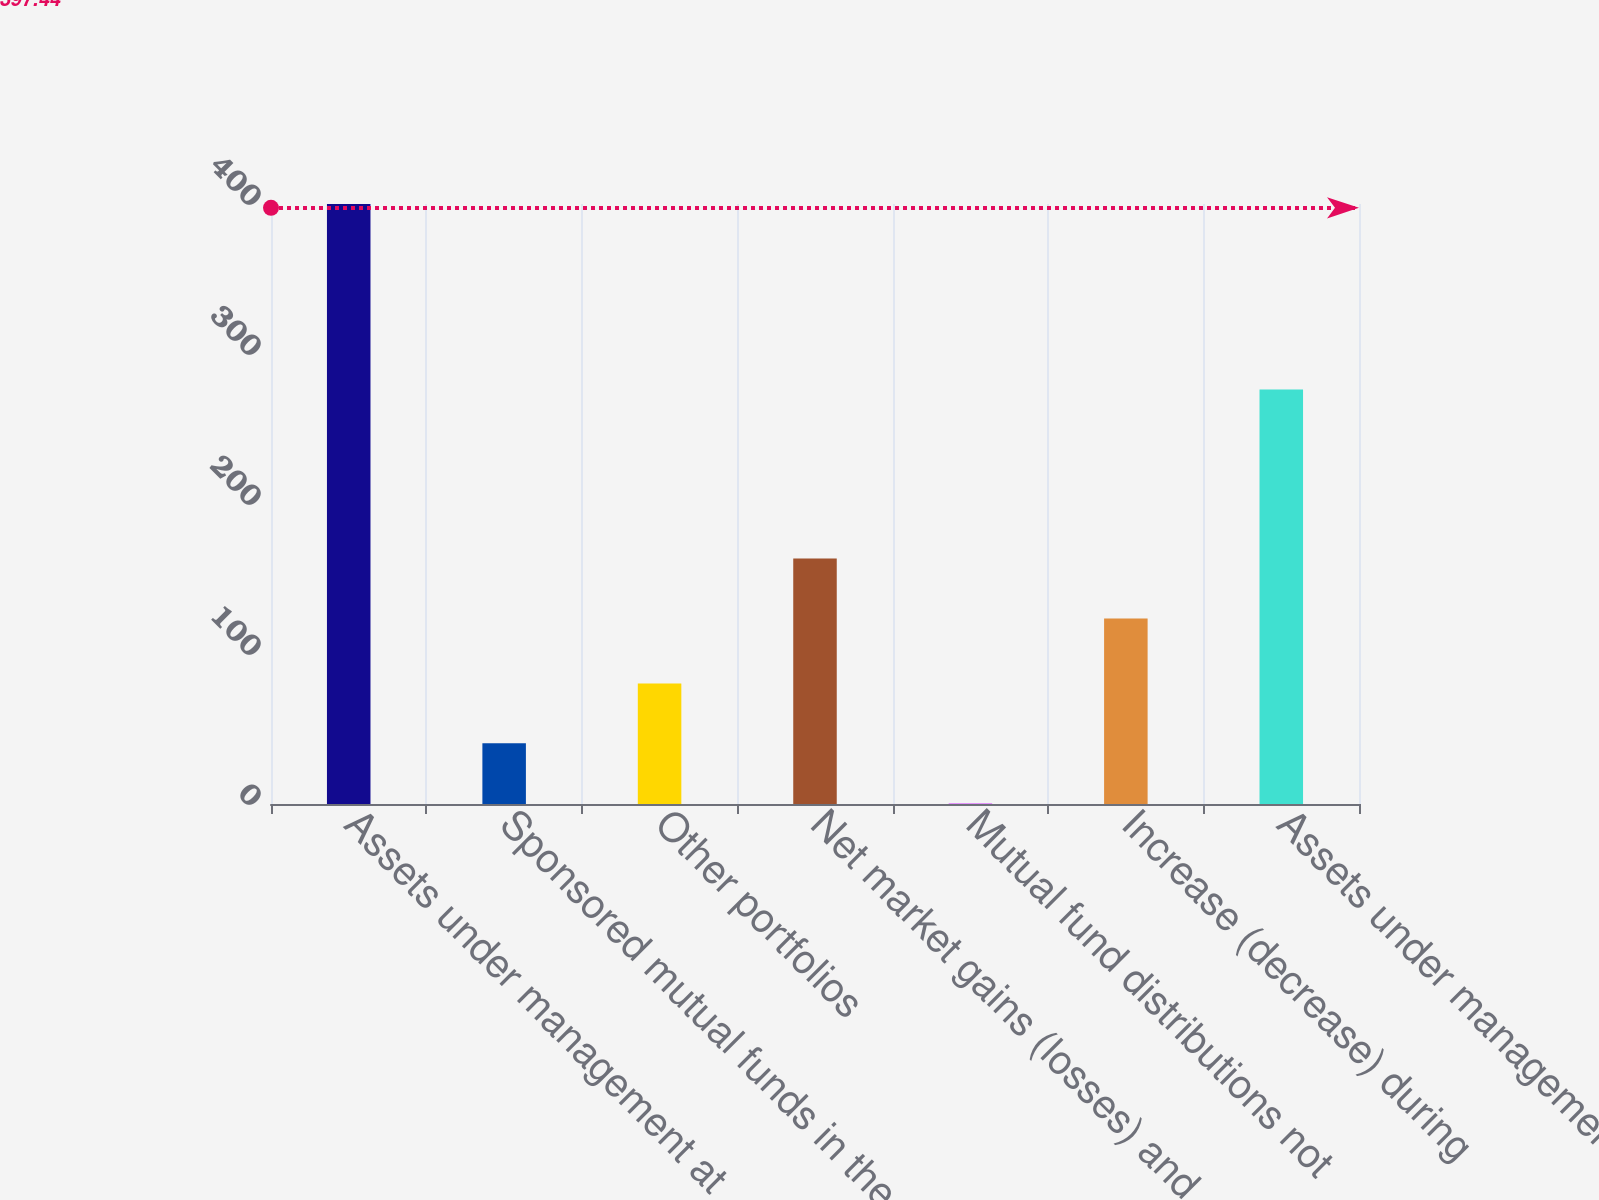Convert chart. <chart><loc_0><loc_0><loc_500><loc_500><bar_chart><fcel>Assets under management at<fcel>Sponsored mutual funds in the<fcel>Other portfolios<fcel>Net market gains (losses) and<fcel>Mutual fund distributions not<fcel>Increase (decrease) during<fcel>Assets under management at end<nl><fcel>400<fcel>40.45<fcel>80.4<fcel>163.65<fcel>0.5<fcel>123.7<fcel>276.3<nl></chart> 